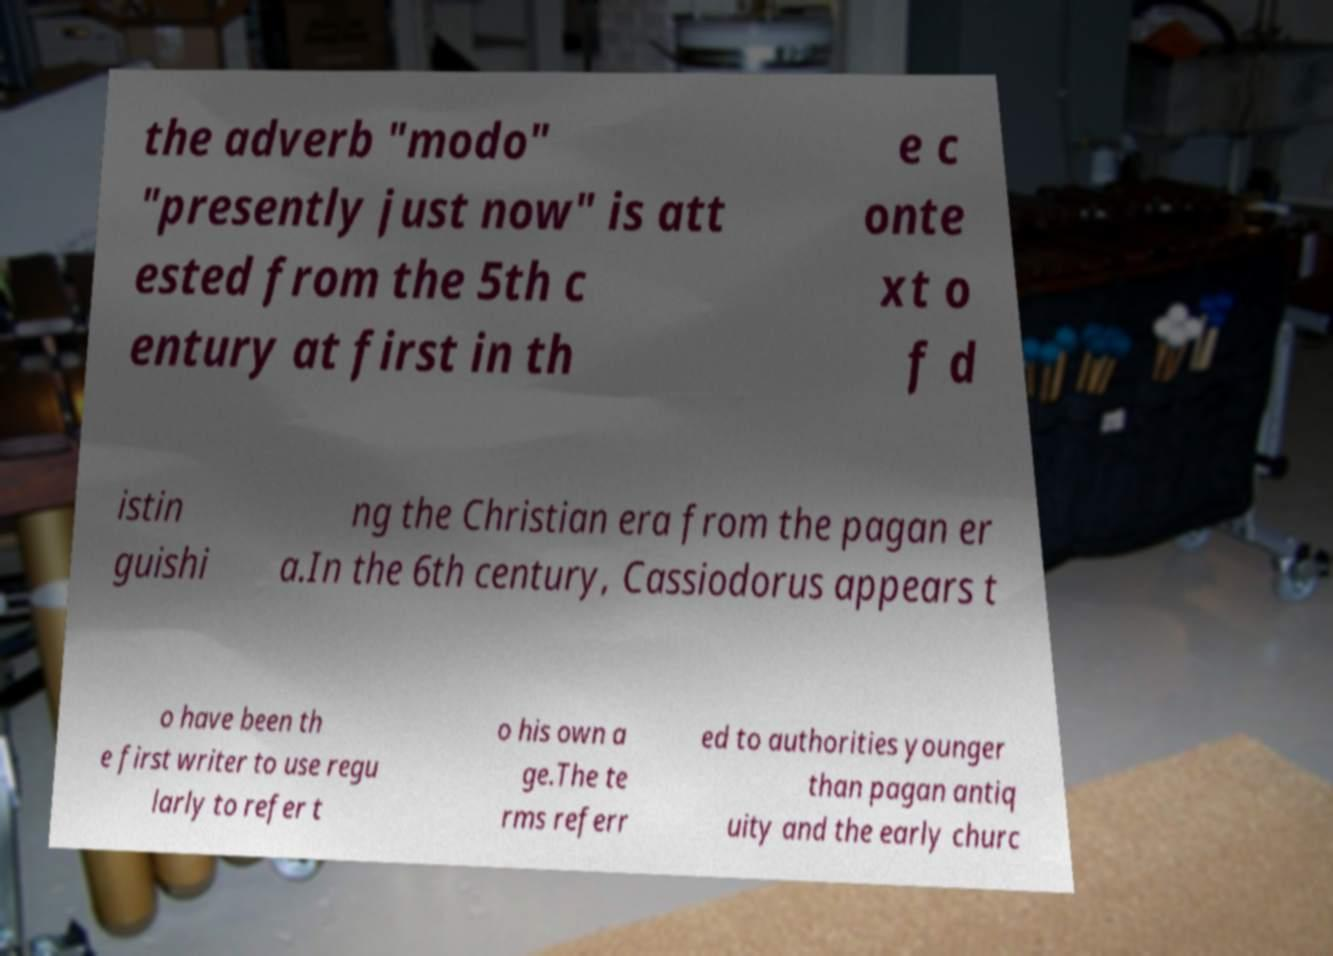Please identify and transcribe the text found in this image. the adverb "modo" "presently just now" is att ested from the 5th c entury at first in th e c onte xt o f d istin guishi ng the Christian era from the pagan er a.In the 6th century, Cassiodorus appears t o have been th e first writer to use regu larly to refer t o his own a ge.The te rms referr ed to authorities younger than pagan antiq uity and the early churc 